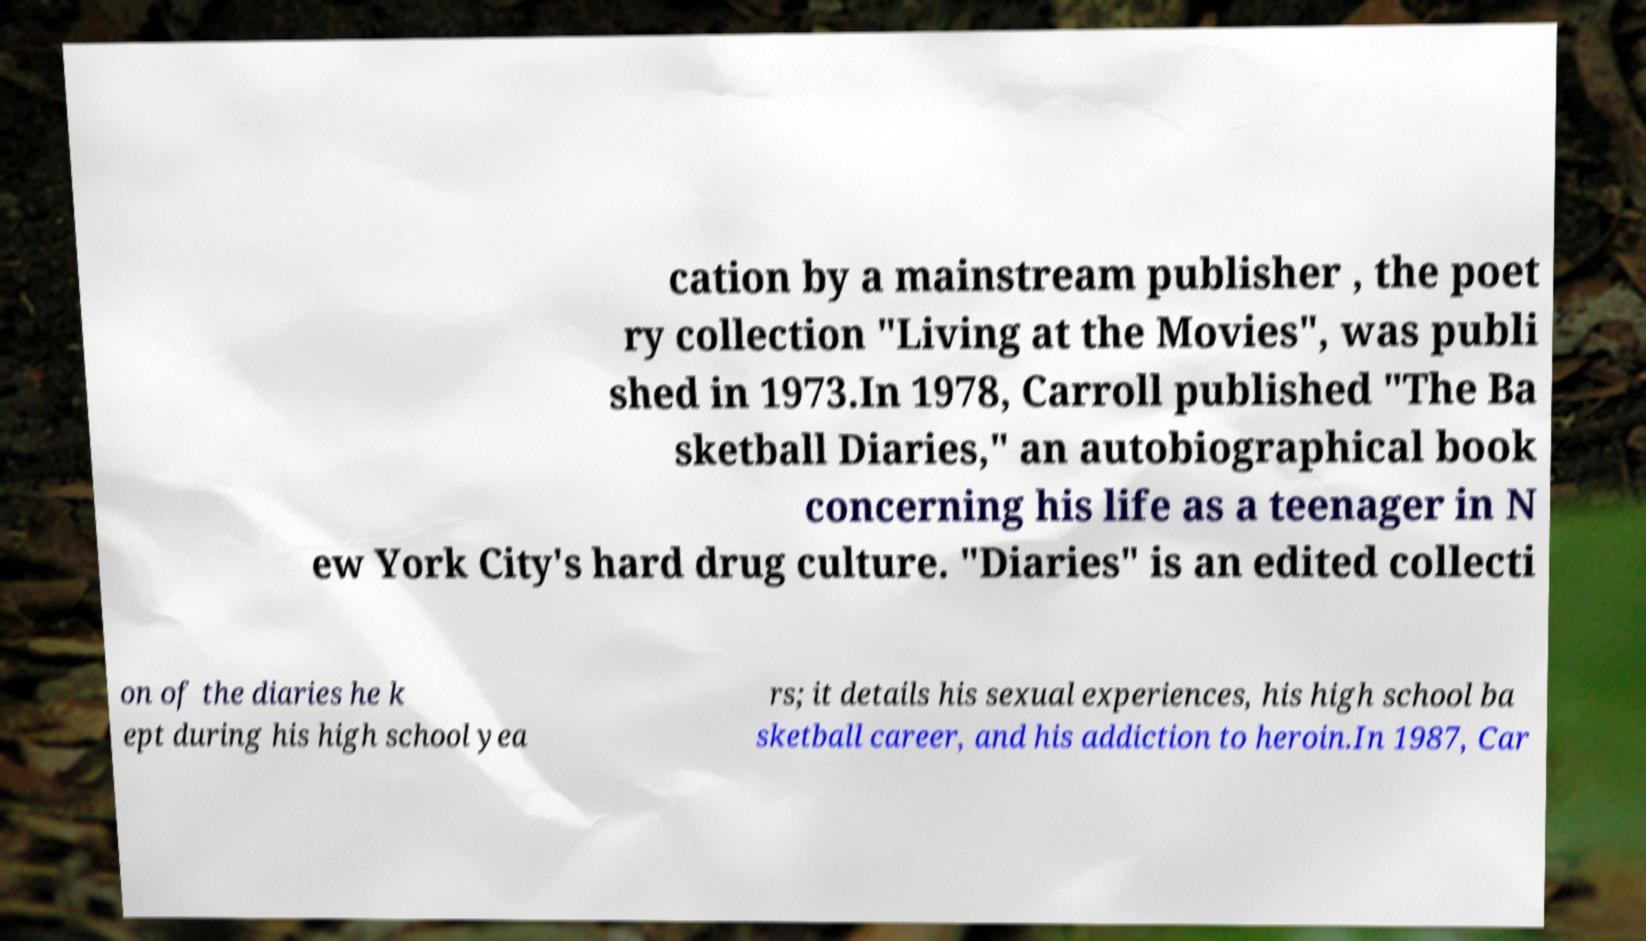Can you read and provide the text displayed in the image?This photo seems to have some interesting text. Can you extract and type it out for me? cation by a mainstream publisher , the poet ry collection "Living at the Movies", was publi shed in 1973.In 1978, Carroll published "The Ba sketball Diaries," an autobiographical book concerning his life as a teenager in N ew York City's hard drug culture. "Diaries" is an edited collecti on of the diaries he k ept during his high school yea rs; it details his sexual experiences, his high school ba sketball career, and his addiction to heroin.In 1987, Car 